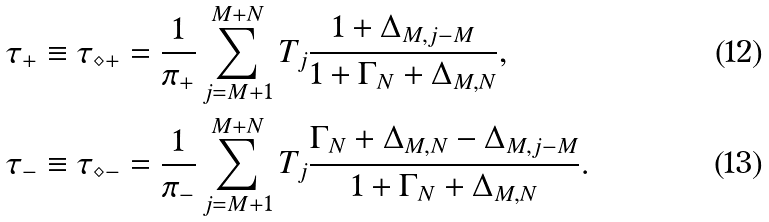Convert formula to latex. <formula><loc_0><loc_0><loc_500><loc_500>& \tau _ { + } \equiv \tau _ { \diamond + } = \frac { 1 } { \pi _ { + } } \sum _ { j = M + 1 } ^ { M + N } T _ { j } \frac { 1 + \Delta _ { M , j - M } } { 1 + \Gamma _ { N } + \Delta _ { M , N } } , \\ & \tau _ { - } \equiv \tau _ { \diamond - } = \frac { 1 } { \pi _ { - } } \sum _ { j = M + 1 } ^ { M + N } T _ { j } \frac { \Gamma _ { N } + \Delta _ { M , N } - \Delta _ { M , j - M } } { 1 + \Gamma _ { N } + \Delta _ { M , N } } .</formula> 